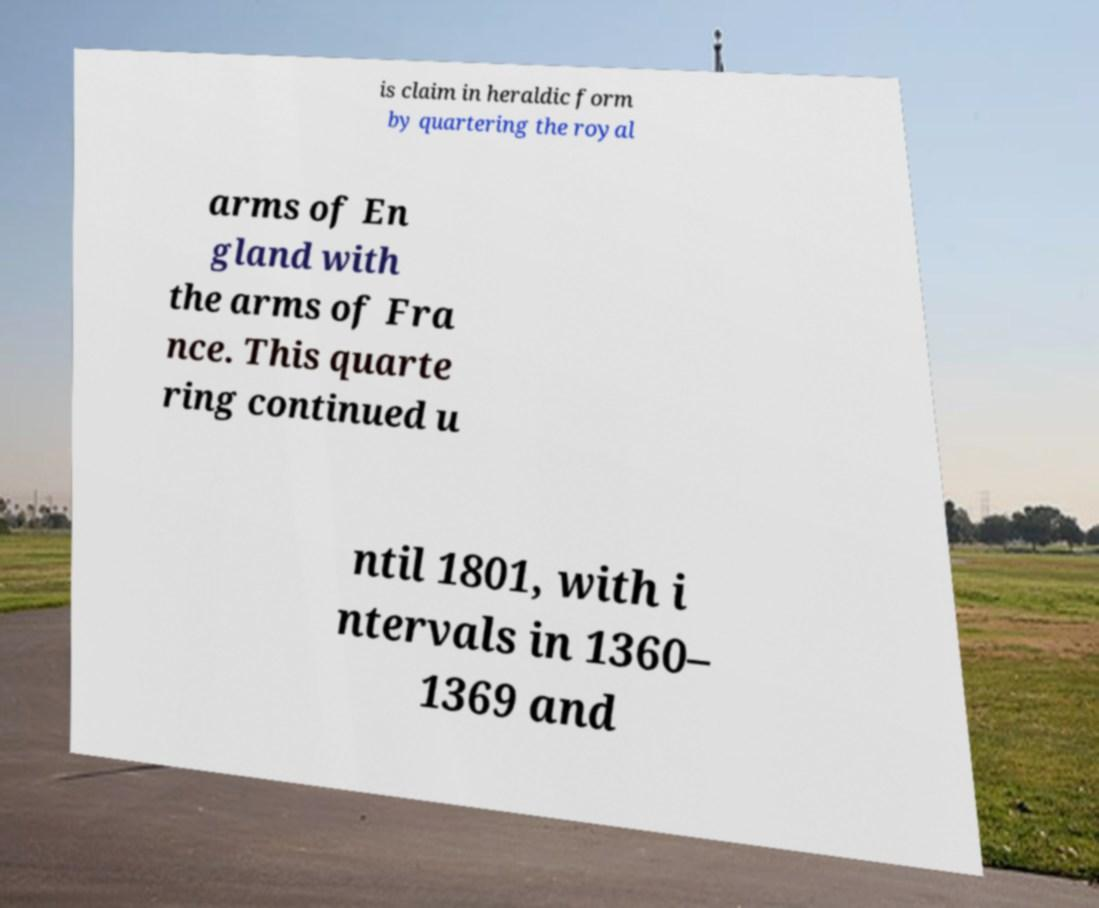Could you assist in decoding the text presented in this image and type it out clearly? is claim in heraldic form by quartering the royal arms of En gland with the arms of Fra nce. This quarte ring continued u ntil 1801, with i ntervals in 1360– 1369 and 